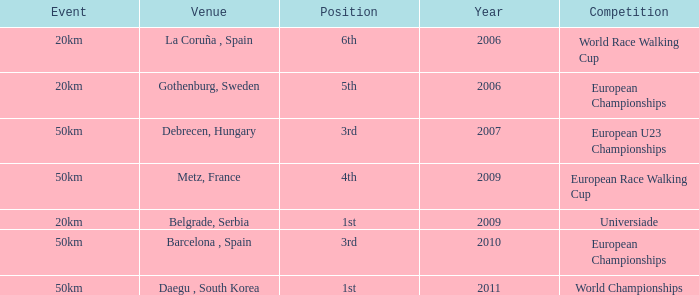Which Competition has an Event of 50km, a Year earlier than 2010 and a Position of 3rd? European U23 Championships. 